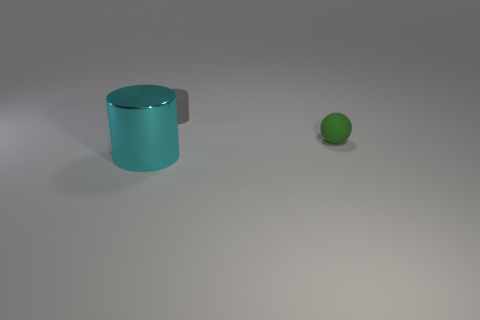Subtract all cyan cylinders. How many cylinders are left? 1 Add 2 tiny blue things. How many objects exist? 5 Subtract 1 balls. How many balls are left? 0 Subtract all spheres. How many objects are left? 2 Subtract all rubber objects. Subtract all large green shiny cylinders. How many objects are left? 1 Add 1 shiny objects. How many shiny objects are left? 2 Add 1 brown balls. How many brown balls exist? 1 Subtract 0 purple spheres. How many objects are left? 3 Subtract all blue spheres. Subtract all red cylinders. How many spheres are left? 1 Subtract all cyan blocks. How many purple spheres are left? 0 